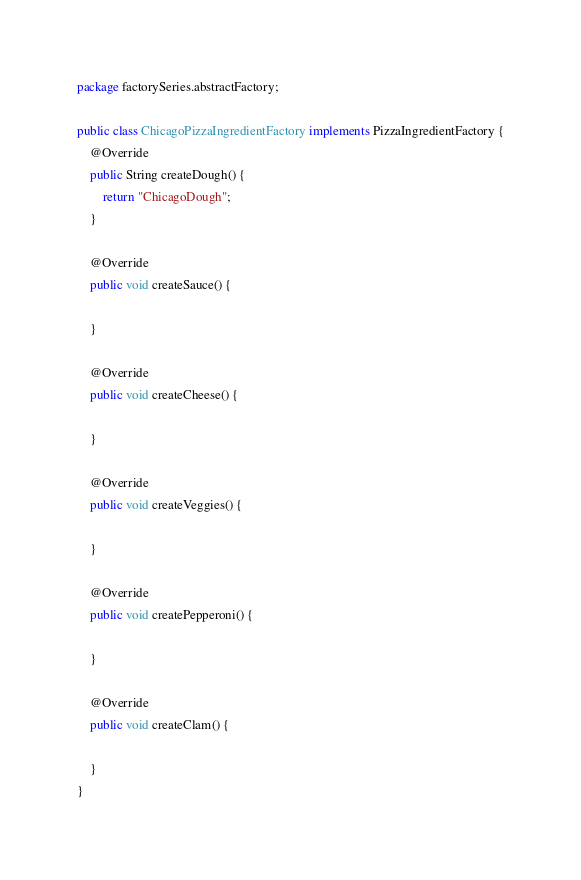<code> <loc_0><loc_0><loc_500><loc_500><_Java_>package factorySeries.abstractFactory;

public class ChicagoPizzaIngredientFactory implements PizzaIngredientFactory {
    @Override
    public String createDough() {
        return "ChicagoDough";
    }

    @Override
    public void createSauce() {

    }

    @Override
    public void createCheese() {

    }

    @Override
    public void createVeggies() {

    }

    @Override
    public void createPepperoni() {

    }

    @Override
    public void createClam() {

    }
}
</code> 